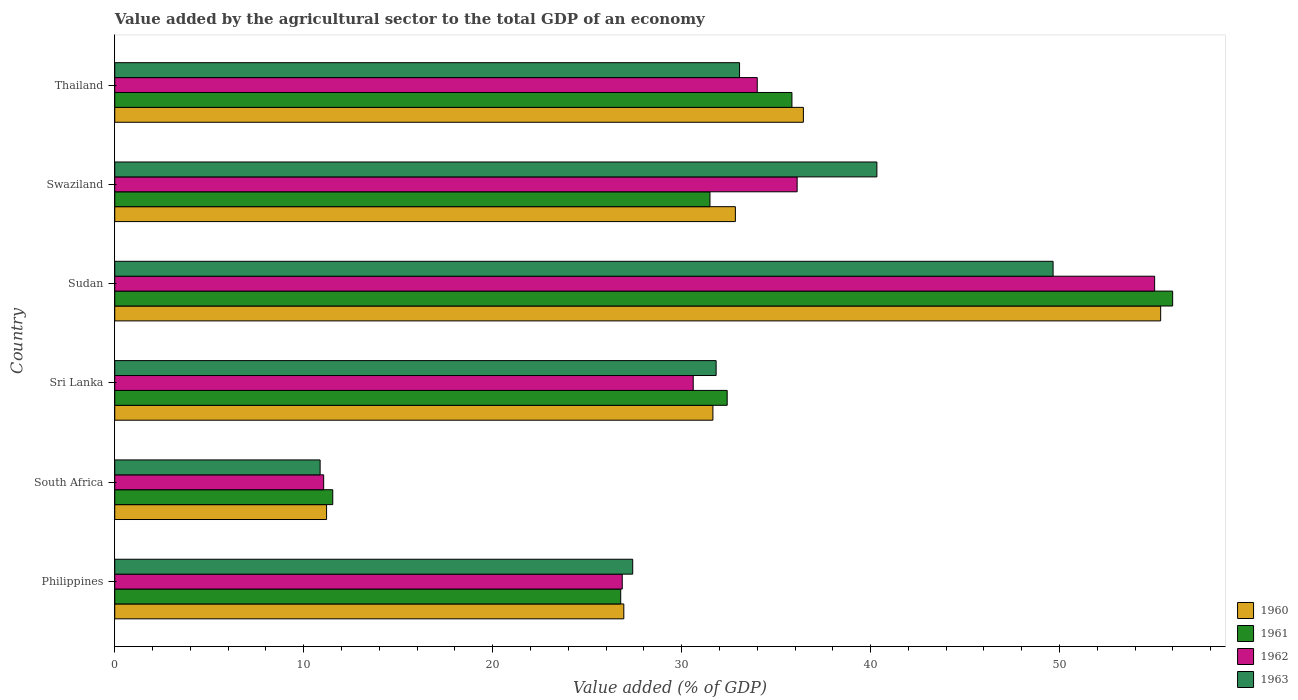How many different coloured bars are there?
Provide a short and direct response. 4. How many groups of bars are there?
Offer a very short reply. 6. Are the number of bars on each tick of the Y-axis equal?
Offer a terse response. Yes. How many bars are there on the 4th tick from the bottom?
Offer a very short reply. 4. What is the value added by the agricultural sector to the total GDP in 1962 in Thailand?
Your answer should be very brief. 34. Across all countries, what is the maximum value added by the agricultural sector to the total GDP in 1960?
Provide a short and direct response. 55.35. Across all countries, what is the minimum value added by the agricultural sector to the total GDP in 1960?
Ensure brevity in your answer.  11.21. In which country was the value added by the agricultural sector to the total GDP in 1963 maximum?
Make the answer very short. Sudan. In which country was the value added by the agricultural sector to the total GDP in 1963 minimum?
Your answer should be very brief. South Africa. What is the total value added by the agricultural sector to the total GDP in 1963 in the graph?
Give a very brief answer. 193.16. What is the difference between the value added by the agricultural sector to the total GDP in 1960 in Philippines and that in Sudan?
Ensure brevity in your answer.  -28.41. What is the difference between the value added by the agricultural sector to the total GDP in 1961 in Sudan and the value added by the agricultural sector to the total GDP in 1962 in Thailand?
Provide a short and direct response. 21.98. What is the average value added by the agricultural sector to the total GDP in 1960 per country?
Offer a very short reply. 32.41. What is the difference between the value added by the agricultural sector to the total GDP in 1963 and value added by the agricultural sector to the total GDP in 1962 in Sudan?
Give a very brief answer. -5.37. What is the ratio of the value added by the agricultural sector to the total GDP in 1963 in South Africa to that in Swaziland?
Keep it short and to the point. 0.27. What is the difference between the highest and the second highest value added by the agricultural sector to the total GDP in 1961?
Your answer should be compact. 20.15. What is the difference between the highest and the lowest value added by the agricultural sector to the total GDP in 1961?
Your answer should be very brief. 44.45. In how many countries, is the value added by the agricultural sector to the total GDP in 1962 greater than the average value added by the agricultural sector to the total GDP in 1962 taken over all countries?
Offer a very short reply. 3. Is it the case that in every country, the sum of the value added by the agricultural sector to the total GDP in 1961 and value added by the agricultural sector to the total GDP in 1963 is greater than the sum of value added by the agricultural sector to the total GDP in 1960 and value added by the agricultural sector to the total GDP in 1962?
Keep it short and to the point. No. What does the 2nd bar from the top in Swaziland represents?
Your answer should be very brief. 1962. What does the 3rd bar from the bottom in Swaziland represents?
Provide a succinct answer. 1962. Is it the case that in every country, the sum of the value added by the agricultural sector to the total GDP in 1963 and value added by the agricultural sector to the total GDP in 1962 is greater than the value added by the agricultural sector to the total GDP in 1961?
Give a very brief answer. Yes. Are all the bars in the graph horizontal?
Provide a short and direct response. Yes. How many countries are there in the graph?
Offer a terse response. 6. What is the difference between two consecutive major ticks on the X-axis?
Ensure brevity in your answer.  10. Does the graph contain any zero values?
Offer a very short reply. No. Where does the legend appear in the graph?
Give a very brief answer. Bottom right. How many legend labels are there?
Your response must be concise. 4. What is the title of the graph?
Make the answer very short. Value added by the agricultural sector to the total GDP of an economy. What is the label or title of the X-axis?
Your response must be concise. Value added (% of GDP). What is the label or title of the Y-axis?
Ensure brevity in your answer.  Country. What is the Value added (% of GDP) of 1960 in Philippines?
Your response must be concise. 26.94. What is the Value added (% of GDP) in 1961 in Philippines?
Your answer should be very brief. 26.78. What is the Value added (% of GDP) in 1962 in Philippines?
Keep it short and to the point. 26.86. What is the Value added (% of GDP) of 1963 in Philippines?
Make the answer very short. 27.41. What is the Value added (% of GDP) of 1960 in South Africa?
Keep it short and to the point. 11.21. What is the Value added (% of GDP) of 1961 in South Africa?
Your response must be concise. 11.54. What is the Value added (% of GDP) in 1962 in South Africa?
Ensure brevity in your answer.  11.06. What is the Value added (% of GDP) in 1963 in South Africa?
Your answer should be very brief. 10.87. What is the Value added (% of GDP) of 1960 in Sri Lanka?
Offer a terse response. 31.66. What is the Value added (% of GDP) in 1961 in Sri Lanka?
Make the answer very short. 32.41. What is the Value added (% of GDP) of 1962 in Sri Lanka?
Provide a succinct answer. 30.61. What is the Value added (% of GDP) of 1963 in Sri Lanka?
Your answer should be very brief. 31.83. What is the Value added (% of GDP) in 1960 in Sudan?
Provide a succinct answer. 55.35. What is the Value added (% of GDP) of 1961 in Sudan?
Offer a very short reply. 55.99. What is the Value added (% of GDP) in 1962 in Sudan?
Give a very brief answer. 55.03. What is the Value added (% of GDP) of 1963 in Sudan?
Make the answer very short. 49.66. What is the Value added (% of GDP) of 1960 in Swaziland?
Make the answer very short. 32.84. What is the Value added (% of GDP) in 1961 in Swaziland?
Offer a terse response. 31.5. What is the Value added (% of GDP) of 1962 in Swaziland?
Offer a very short reply. 36.11. What is the Value added (% of GDP) in 1963 in Swaziland?
Your answer should be very brief. 40.33. What is the Value added (% of GDP) in 1960 in Thailand?
Offer a terse response. 36.44. What is the Value added (% of GDP) in 1961 in Thailand?
Ensure brevity in your answer.  35.84. What is the Value added (% of GDP) of 1962 in Thailand?
Offer a very short reply. 34. What is the Value added (% of GDP) in 1963 in Thailand?
Provide a short and direct response. 33.07. Across all countries, what is the maximum Value added (% of GDP) of 1960?
Provide a succinct answer. 55.35. Across all countries, what is the maximum Value added (% of GDP) in 1961?
Your answer should be very brief. 55.99. Across all countries, what is the maximum Value added (% of GDP) of 1962?
Provide a succinct answer. 55.03. Across all countries, what is the maximum Value added (% of GDP) of 1963?
Give a very brief answer. 49.66. Across all countries, what is the minimum Value added (% of GDP) of 1960?
Your answer should be very brief. 11.21. Across all countries, what is the minimum Value added (% of GDP) in 1961?
Give a very brief answer. 11.54. Across all countries, what is the minimum Value added (% of GDP) in 1962?
Your answer should be very brief. 11.06. Across all countries, what is the minimum Value added (% of GDP) of 1963?
Ensure brevity in your answer.  10.87. What is the total Value added (% of GDP) in 1960 in the graph?
Make the answer very short. 194.45. What is the total Value added (% of GDP) of 1961 in the graph?
Offer a very short reply. 194.05. What is the total Value added (% of GDP) in 1962 in the graph?
Offer a very short reply. 193.68. What is the total Value added (% of GDP) of 1963 in the graph?
Ensure brevity in your answer.  193.16. What is the difference between the Value added (% of GDP) in 1960 in Philippines and that in South Africa?
Ensure brevity in your answer.  15.73. What is the difference between the Value added (% of GDP) of 1961 in Philippines and that in South Africa?
Offer a very short reply. 15.24. What is the difference between the Value added (% of GDP) of 1962 in Philippines and that in South Africa?
Give a very brief answer. 15.8. What is the difference between the Value added (% of GDP) in 1963 in Philippines and that in South Africa?
Offer a terse response. 16.54. What is the difference between the Value added (% of GDP) in 1960 in Philippines and that in Sri Lanka?
Your response must be concise. -4.72. What is the difference between the Value added (% of GDP) in 1961 in Philippines and that in Sri Lanka?
Your answer should be compact. -5.63. What is the difference between the Value added (% of GDP) in 1962 in Philippines and that in Sri Lanka?
Offer a terse response. -3.76. What is the difference between the Value added (% of GDP) in 1963 in Philippines and that in Sri Lanka?
Ensure brevity in your answer.  -4.41. What is the difference between the Value added (% of GDP) of 1960 in Philippines and that in Sudan?
Ensure brevity in your answer.  -28.41. What is the difference between the Value added (% of GDP) in 1961 in Philippines and that in Sudan?
Give a very brief answer. -29.21. What is the difference between the Value added (% of GDP) of 1962 in Philippines and that in Sudan?
Make the answer very short. -28.18. What is the difference between the Value added (% of GDP) in 1963 in Philippines and that in Sudan?
Offer a terse response. -22.25. What is the difference between the Value added (% of GDP) of 1960 in Philippines and that in Swaziland?
Give a very brief answer. -5.9. What is the difference between the Value added (% of GDP) in 1961 in Philippines and that in Swaziland?
Provide a succinct answer. -4.72. What is the difference between the Value added (% of GDP) of 1962 in Philippines and that in Swaziland?
Give a very brief answer. -9.26. What is the difference between the Value added (% of GDP) of 1963 in Philippines and that in Swaziland?
Your response must be concise. -12.92. What is the difference between the Value added (% of GDP) of 1960 in Philippines and that in Thailand?
Offer a terse response. -9.5. What is the difference between the Value added (% of GDP) in 1961 in Philippines and that in Thailand?
Keep it short and to the point. -9.06. What is the difference between the Value added (% of GDP) of 1962 in Philippines and that in Thailand?
Your response must be concise. -7.14. What is the difference between the Value added (% of GDP) in 1963 in Philippines and that in Thailand?
Provide a short and direct response. -5.65. What is the difference between the Value added (% of GDP) in 1960 in South Africa and that in Sri Lanka?
Provide a short and direct response. -20.45. What is the difference between the Value added (% of GDP) of 1961 in South Africa and that in Sri Lanka?
Give a very brief answer. -20.87. What is the difference between the Value added (% of GDP) of 1962 in South Africa and that in Sri Lanka?
Your response must be concise. -19.56. What is the difference between the Value added (% of GDP) in 1963 in South Africa and that in Sri Lanka?
Provide a short and direct response. -20.96. What is the difference between the Value added (% of GDP) in 1960 in South Africa and that in Sudan?
Offer a very short reply. -44.14. What is the difference between the Value added (% of GDP) of 1961 in South Africa and that in Sudan?
Ensure brevity in your answer.  -44.45. What is the difference between the Value added (% of GDP) of 1962 in South Africa and that in Sudan?
Give a very brief answer. -43.98. What is the difference between the Value added (% of GDP) of 1963 in South Africa and that in Sudan?
Make the answer very short. -38.79. What is the difference between the Value added (% of GDP) in 1960 in South Africa and that in Swaziland?
Your response must be concise. -21.63. What is the difference between the Value added (% of GDP) of 1961 in South Africa and that in Swaziland?
Ensure brevity in your answer.  -19.96. What is the difference between the Value added (% of GDP) in 1962 in South Africa and that in Swaziland?
Your answer should be very brief. -25.06. What is the difference between the Value added (% of GDP) in 1963 in South Africa and that in Swaziland?
Provide a short and direct response. -29.46. What is the difference between the Value added (% of GDP) in 1960 in South Africa and that in Thailand?
Your response must be concise. -25.23. What is the difference between the Value added (% of GDP) of 1961 in South Africa and that in Thailand?
Offer a very short reply. -24.3. What is the difference between the Value added (% of GDP) of 1962 in South Africa and that in Thailand?
Your answer should be very brief. -22.95. What is the difference between the Value added (% of GDP) of 1963 in South Africa and that in Thailand?
Keep it short and to the point. -22.2. What is the difference between the Value added (% of GDP) in 1960 in Sri Lanka and that in Sudan?
Your answer should be very brief. -23.7. What is the difference between the Value added (% of GDP) of 1961 in Sri Lanka and that in Sudan?
Provide a succinct answer. -23.58. What is the difference between the Value added (% of GDP) of 1962 in Sri Lanka and that in Sudan?
Your response must be concise. -24.42. What is the difference between the Value added (% of GDP) of 1963 in Sri Lanka and that in Sudan?
Ensure brevity in your answer.  -17.83. What is the difference between the Value added (% of GDP) of 1960 in Sri Lanka and that in Swaziland?
Keep it short and to the point. -1.19. What is the difference between the Value added (% of GDP) of 1961 in Sri Lanka and that in Swaziland?
Provide a short and direct response. 0.91. What is the difference between the Value added (% of GDP) in 1962 in Sri Lanka and that in Swaziland?
Make the answer very short. -5.5. What is the difference between the Value added (% of GDP) in 1963 in Sri Lanka and that in Swaziland?
Your answer should be compact. -8.51. What is the difference between the Value added (% of GDP) of 1960 in Sri Lanka and that in Thailand?
Keep it short and to the point. -4.79. What is the difference between the Value added (% of GDP) in 1961 in Sri Lanka and that in Thailand?
Provide a short and direct response. -3.43. What is the difference between the Value added (% of GDP) of 1962 in Sri Lanka and that in Thailand?
Offer a terse response. -3.39. What is the difference between the Value added (% of GDP) in 1963 in Sri Lanka and that in Thailand?
Provide a short and direct response. -1.24. What is the difference between the Value added (% of GDP) of 1960 in Sudan and that in Swaziland?
Offer a terse response. 22.51. What is the difference between the Value added (% of GDP) in 1961 in Sudan and that in Swaziland?
Give a very brief answer. 24.49. What is the difference between the Value added (% of GDP) in 1962 in Sudan and that in Swaziland?
Keep it short and to the point. 18.92. What is the difference between the Value added (% of GDP) in 1963 in Sudan and that in Swaziland?
Ensure brevity in your answer.  9.32. What is the difference between the Value added (% of GDP) in 1960 in Sudan and that in Thailand?
Your response must be concise. 18.91. What is the difference between the Value added (% of GDP) of 1961 in Sudan and that in Thailand?
Provide a short and direct response. 20.15. What is the difference between the Value added (% of GDP) of 1962 in Sudan and that in Thailand?
Give a very brief answer. 21.03. What is the difference between the Value added (% of GDP) in 1963 in Sudan and that in Thailand?
Make the answer very short. 16.59. What is the difference between the Value added (% of GDP) of 1960 in Swaziland and that in Thailand?
Keep it short and to the point. -3.6. What is the difference between the Value added (% of GDP) in 1961 in Swaziland and that in Thailand?
Offer a very short reply. -4.34. What is the difference between the Value added (% of GDP) in 1962 in Swaziland and that in Thailand?
Keep it short and to the point. 2.11. What is the difference between the Value added (% of GDP) of 1963 in Swaziland and that in Thailand?
Offer a terse response. 7.27. What is the difference between the Value added (% of GDP) of 1960 in Philippines and the Value added (% of GDP) of 1961 in South Africa?
Offer a terse response. 15.4. What is the difference between the Value added (% of GDP) of 1960 in Philippines and the Value added (% of GDP) of 1962 in South Africa?
Provide a short and direct response. 15.88. What is the difference between the Value added (% of GDP) in 1960 in Philippines and the Value added (% of GDP) in 1963 in South Africa?
Keep it short and to the point. 16.07. What is the difference between the Value added (% of GDP) of 1961 in Philippines and the Value added (% of GDP) of 1962 in South Africa?
Provide a succinct answer. 15.72. What is the difference between the Value added (% of GDP) of 1961 in Philippines and the Value added (% of GDP) of 1963 in South Africa?
Offer a very short reply. 15.91. What is the difference between the Value added (% of GDP) of 1962 in Philippines and the Value added (% of GDP) of 1963 in South Africa?
Make the answer very short. 15.99. What is the difference between the Value added (% of GDP) of 1960 in Philippines and the Value added (% of GDP) of 1961 in Sri Lanka?
Ensure brevity in your answer.  -5.47. What is the difference between the Value added (% of GDP) in 1960 in Philippines and the Value added (% of GDP) in 1962 in Sri Lanka?
Your answer should be compact. -3.67. What is the difference between the Value added (% of GDP) in 1960 in Philippines and the Value added (% of GDP) in 1963 in Sri Lanka?
Keep it short and to the point. -4.89. What is the difference between the Value added (% of GDP) in 1961 in Philippines and the Value added (% of GDP) in 1962 in Sri Lanka?
Ensure brevity in your answer.  -3.84. What is the difference between the Value added (% of GDP) in 1961 in Philippines and the Value added (% of GDP) in 1963 in Sri Lanka?
Offer a terse response. -5.05. What is the difference between the Value added (% of GDP) of 1962 in Philippines and the Value added (% of GDP) of 1963 in Sri Lanka?
Give a very brief answer. -4.97. What is the difference between the Value added (% of GDP) of 1960 in Philippines and the Value added (% of GDP) of 1961 in Sudan?
Your response must be concise. -29.05. What is the difference between the Value added (% of GDP) in 1960 in Philippines and the Value added (% of GDP) in 1962 in Sudan?
Your answer should be compact. -28.09. What is the difference between the Value added (% of GDP) of 1960 in Philippines and the Value added (% of GDP) of 1963 in Sudan?
Offer a very short reply. -22.72. What is the difference between the Value added (% of GDP) of 1961 in Philippines and the Value added (% of GDP) of 1962 in Sudan?
Offer a very short reply. -28.26. What is the difference between the Value added (% of GDP) in 1961 in Philippines and the Value added (% of GDP) in 1963 in Sudan?
Your answer should be very brief. -22.88. What is the difference between the Value added (% of GDP) of 1962 in Philippines and the Value added (% of GDP) of 1963 in Sudan?
Your answer should be very brief. -22.8. What is the difference between the Value added (% of GDP) in 1960 in Philippines and the Value added (% of GDP) in 1961 in Swaziland?
Keep it short and to the point. -4.56. What is the difference between the Value added (% of GDP) in 1960 in Philippines and the Value added (% of GDP) in 1962 in Swaziland?
Keep it short and to the point. -9.17. What is the difference between the Value added (% of GDP) in 1960 in Philippines and the Value added (% of GDP) in 1963 in Swaziland?
Provide a short and direct response. -13.39. What is the difference between the Value added (% of GDP) of 1961 in Philippines and the Value added (% of GDP) of 1962 in Swaziland?
Offer a very short reply. -9.34. What is the difference between the Value added (% of GDP) of 1961 in Philippines and the Value added (% of GDP) of 1963 in Swaziland?
Give a very brief answer. -13.56. What is the difference between the Value added (% of GDP) in 1962 in Philippines and the Value added (% of GDP) in 1963 in Swaziland?
Your response must be concise. -13.48. What is the difference between the Value added (% of GDP) in 1960 in Philippines and the Value added (% of GDP) in 1961 in Thailand?
Make the answer very short. -8.9. What is the difference between the Value added (% of GDP) in 1960 in Philippines and the Value added (% of GDP) in 1962 in Thailand?
Your answer should be compact. -7.06. What is the difference between the Value added (% of GDP) in 1960 in Philippines and the Value added (% of GDP) in 1963 in Thailand?
Your answer should be compact. -6.12. What is the difference between the Value added (% of GDP) in 1961 in Philippines and the Value added (% of GDP) in 1962 in Thailand?
Offer a terse response. -7.23. What is the difference between the Value added (% of GDP) in 1961 in Philippines and the Value added (% of GDP) in 1963 in Thailand?
Your answer should be very brief. -6.29. What is the difference between the Value added (% of GDP) in 1962 in Philippines and the Value added (% of GDP) in 1963 in Thailand?
Provide a succinct answer. -6.21. What is the difference between the Value added (% of GDP) in 1960 in South Africa and the Value added (% of GDP) in 1961 in Sri Lanka?
Your answer should be compact. -21.2. What is the difference between the Value added (% of GDP) in 1960 in South Africa and the Value added (% of GDP) in 1962 in Sri Lanka?
Your response must be concise. -19.4. What is the difference between the Value added (% of GDP) in 1960 in South Africa and the Value added (% of GDP) in 1963 in Sri Lanka?
Provide a short and direct response. -20.62. What is the difference between the Value added (% of GDP) in 1961 in South Africa and the Value added (% of GDP) in 1962 in Sri Lanka?
Your answer should be very brief. -19.08. What is the difference between the Value added (% of GDP) in 1961 in South Africa and the Value added (% of GDP) in 1963 in Sri Lanka?
Your response must be concise. -20.29. What is the difference between the Value added (% of GDP) of 1962 in South Africa and the Value added (% of GDP) of 1963 in Sri Lanka?
Keep it short and to the point. -20.77. What is the difference between the Value added (% of GDP) in 1960 in South Africa and the Value added (% of GDP) in 1961 in Sudan?
Give a very brief answer. -44.78. What is the difference between the Value added (% of GDP) in 1960 in South Africa and the Value added (% of GDP) in 1962 in Sudan?
Provide a succinct answer. -43.82. What is the difference between the Value added (% of GDP) in 1960 in South Africa and the Value added (% of GDP) in 1963 in Sudan?
Make the answer very short. -38.45. What is the difference between the Value added (% of GDP) of 1961 in South Africa and the Value added (% of GDP) of 1962 in Sudan?
Your response must be concise. -43.5. What is the difference between the Value added (% of GDP) of 1961 in South Africa and the Value added (% of GDP) of 1963 in Sudan?
Ensure brevity in your answer.  -38.12. What is the difference between the Value added (% of GDP) of 1962 in South Africa and the Value added (% of GDP) of 1963 in Sudan?
Your response must be concise. -38.6. What is the difference between the Value added (% of GDP) of 1960 in South Africa and the Value added (% of GDP) of 1961 in Swaziland?
Your response must be concise. -20.29. What is the difference between the Value added (% of GDP) in 1960 in South Africa and the Value added (% of GDP) in 1962 in Swaziland?
Provide a short and direct response. -24.9. What is the difference between the Value added (% of GDP) of 1960 in South Africa and the Value added (% of GDP) of 1963 in Swaziland?
Give a very brief answer. -29.12. What is the difference between the Value added (% of GDP) of 1961 in South Africa and the Value added (% of GDP) of 1962 in Swaziland?
Your response must be concise. -24.58. What is the difference between the Value added (% of GDP) in 1961 in South Africa and the Value added (% of GDP) in 1963 in Swaziland?
Your answer should be very brief. -28.8. What is the difference between the Value added (% of GDP) of 1962 in South Africa and the Value added (% of GDP) of 1963 in Swaziland?
Ensure brevity in your answer.  -29.28. What is the difference between the Value added (% of GDP) in 1960 in South Africa and the Value added (% of GDP) in 1961 in Thailand?
Offer a very short reply. -24.63. What is the difference between the Value added (% of GDP) of 1960 in South Africa and the Value added (% of GDP) of 1962 in Thailand?
Make the answer very short. -22.79. What is the difference between the Value added (% of GDP) of 1960 in South Africa and the Value added (% of GDP) of 1963 in Thailand?
Offer a very short reply. -21.86. What is the difference between the Value added (% of GDP) in 1961 in South Africa and the Value added (% of GDP) in 1962 in Thailand?
Provide a succinct answer. -22.47. What is the difference between the Value added (% of GDP) in 1961 in South Africa and the Value added (% of GDP) in 1963 in Thailand?
Make the answer very short. -21.53. What is the difference between the Value added (% of GDP) of 1962 in South Africa and the Value added (% of GDP) of 1963 in Thailand?
Provide a short and direct response. -22.01. What is the difference between the Value added (% of GDP) of 1960 in Sri Lanka and the Value added (% of GDP) of 1961 in Sudan?
Provide a succinct answer. -24.33. What is the difference between the Value added (% of GDP) in 1960 in Sri Lanka and the Value added (% of GDP) in 1962 in Sudan?
Your answer should be very brief. -23.38. What is the difference between the Value added (% of GDP) of 1960 in Sri Lanka and the Value added (% of GDP) of 1963 in Sudan?
Your response must be concise. -18. What is the difference between the Value added (% of GDP) of 1961 in Sri Lanka and the Value added (% of GDP) of 1962 in Sudan?
Give a very brief answer. -22.62. What is the difference between the Value added (% of GDP) of 1961 in Sri Lanka and the Value added (% of GDP) of 1963 in Sudan?
Make the answer very short. -17.25. What is the difference between the Value added (% of GDP) in 1962 in Sri Lanka and the Value added (% of GDP) in 1963 in Sudan?
Provide a succinct answer. -19.04. What is the difference between the Value added (% of GDP) of 1960 in Sri Lanka and the Value added (% of GDP) of 1961 in Swaziland?
Provide a short and direct response. 0.16. What is the difference between the Value added (% of GDP) of 1960 in Sri Lanka and the Value added (% of GDP) of 1962 in Swaziland?
Give a very brief answer. -4.46. What is the difference between the Value added (% of GDP) of 1960 in Sri Lanka and the Value added (% of GDP) of 1963 in Swaziland?
Your response must be concise. -8.68. What is the difference between the Value added (% of GDP) of 1961 in Sri Lanka and the Value added (% of GDP) of 1962 in Swaziland?
Provide a succinct answer. -3.7. What is the difference between the Value added (% of GDP) of 1961 in Sri Lanka and the Value added (% of GDP) of 1963 in Swaziland?
Your answer should be compact. -7.92. What is the difference between the Value added (% of GDP) of 1962 in Sri Lanka and the Value added (% of GDP) of 1963 in Swaziland?
Give a very brief answer. -9.72. What is the difference between the Value added (% of GDP) of 1960 in Sri Lanka and the Value added (% of GDP) of 1961 in Thailand?
Provide a short and direct response. -4.18. What is the difference between the Value added (% of GDP) of 1960 in Sri Lanka and the Value added (% of GDP) of 1962 in Thailand?
Keep it short and to the point. -2.35. What is the difference between the Value added (% of GDP) of 1960 in Sri Lanka and the Value added (% of GDP) of 1963 in Thailand?
Ensure brevity in your answer.  -1.41. What is the difference between the Value added (% of GDP) of 1961 in Sri Lanka and the Value added (% of GDP) of 1962 in Thailand?
Your response must be concise. -1.59. What is the difference between the Value added (% of GDP) in 1961 in Sri Lanka and the Value added (% of GDP) in 1963 in Thailand?
Give a very brief answer. -0.65. What is the difference between the Value added (% of GDP) in 1962 in Sri Lanka and the Value added (% of GDP) in 1963 in Thailand?
Your answer should be very brief. -2.45. What is the difference between the Value added (% of GDP) of 1960 in Sudan and the Value added (% of GDP) of 1961 in Swaziland?
Your response must be concise. 23.85. What is the difference between the Value added (% of GDP) in 1960 in Sudan and the Value added (% of GDP) in 1962 in Swaziland?
Offer a terse response. 19.24. What is the difference between the Value added (% of GDP) in 1960 in Sudan and the Value added (% of GDP) in 1963 in Swaziland?
Provide a short and direct response. 15.02. What is the difference between the Value added (% of GDP) in 1961 in Sudan and the Value added (% of GDP) in 1962 in Swaziland?
Keep it short and to the point. 19.87. What is the difference between the Value added (% of GDP) in 1961 in Sudan and the Value added (% of GDP) in 1963 in Swaziland?
Offer a very short reply. 15.65. What is the difference between the Value added (% of GDP) of 1962 in Sudan and the Value added (% of GDP) of 1963 in Swaziland?
Give a very brief answer. 14.7. What is the difference between the Value added (% of GDP) of 1960 in Sudan and the Value added (% of GDP) of 1961 in Thailand?
Ensure brevity in your answer.  19.51. What is the difference between the Value added (% of GDP) of 1960 in Sudan and the Value added (% of GDP) of 1962 in Thailand?
Make the answer very short. 21.35. What is the difference between the Value added (% of GDP) in 1960 in Sudan and the Value added (% of GDP) in 1963 in Thailand?
Offer a very short reply. 22.29. What is the difference between the Value added (% of GDP) of 1961 in Sudan and the Value added (% of GDP) of 1962 in Thailand?
Your answer should be very brief. 21.98. What is the difference between the Value added (% of GDP) in 1961 in Sudan and the Value added (% of GDP) in 1963 in Thailand?
Provide a succinct answer. 22.92. What is the difference between the Value added (% of GDP) of 1962 in Sudan and the Value added (% of GDP) of 1963 in Thailand?
Ensure brevity in your answer.  21.97. What is the difference between the Value added (% of GDP) in 1960 in Swaziland and the Value added (% of GDP) in 1961 in Thailand?
Provide a short and direct response. -2.99. What is the difference between the Value added (% of GDP) of 1960 in Swaziland and the Value added (% of GDP) of 1962 in Thailand?
Offer a very short reply. -1.16. What is the difference between the Value added (% of GDP) in 1960 in Swaziland and the Value added (% of GDP) in 1963 in Thailand?
Ensure brevity in your answer.  -0.22. What is the difference between the Value added (% of GDP) in 1961 in Swaziland and the Value added (% of GDP) in 1962 in Thailand?
Offer a terse response. -2.5. What is the difference between the Value added (% of GDP) in 1961 in Swaziland and the Value added (% of GDP) in 1963 in Thailand?
Offer a terse response. -1.57. What is the difference between the Value added (% of GDP) in 1962 in Swaziland and the Value added (% of GDP) in 1963 in Thailand?
Give a very brief answer. 3.05. What is the average Value added (% of GDP) in 1960 per country?
Your response must be concise. 32.41. What is the average Value added (% of GDP) of 1961 per country?
Your response must be concise. 32.34. What is the average Value added (% of GDP) in 1962 per country?
Provide a succinct answer. 32.28. What is the average Value added (% of GDP) in 1963 per country?
Your answer should be very brief. 32.19. What is the difference between the Value added (% of GDP) in 1960 and Value added (% of GDP) in 1961 in Philippines?
Give a very brief answer. 0.16. What is the difference between the Value added (% of GDP) in 1960 and Value added (% of GDP) in 1962 in Philippines?
Provide a short and direct response. 0.08. What is the difference between the Value added (% of GDP) in 1960 and Value added (% of GDP) in 1963 in Philippines?
Give a very brief answer. -0.47. What is the difference between the Value added (% of GDP) in 1961 and Value added (% of GDP) in 1962 in Philippines?
Keep it short and to the point. -0.08. What is the difference between the Value added (% of GDP) in 1961 and Value added (% of GDP) in 1963 in Philippines?
Give a very brief answer. -0.64. What is the difference between the Value added (% of GDP) in 1962 and Value added (% of GDP) in 1963 in Philippines?
Provide a short and direct response. -0.55. What is the difference between the Value added (% of GDP) in 1960 and Value added (% of GDP) in 1961 in South Africa?
Your response must be concise. -0.33. What is the difference between the Value added (% of GDP) of 1960 and Value added (% of GDP) of 1962 in South Africa?
Provide a succinct answer. 0.15. What is the difference between the Value added (% of GDP) in 1960 and Value added (% of GDP) in 1963 in South Africa?
Provide a succinct answer. 0.34. What is the difference between the Value added (% of GDP) in 1961 and Value added (% of GDP) in 1962 in South Africa?
Provide a short and direct response. 0.48. What is the difference between the Value added (% of GDP) of 1961 and Value added (% of GDP) of 1963 in South Africa?
Your response must be concise. 0.67. What is the difference between the Value added (% of GDP) of 1962 and Value added (% of GDP) of 1963 in South Africa?
Your answer should be very brief. 0.19. What is the difference between the Value added (% of GDP) of 1960 and Value added (% of GDP) of 1961 in Sri Lanka?
Offer a very short reply. -0.76. What is the difference between the Value added (% of GDP) of 1960 and Value added (% of GDP) of 1962 in Sri Lanka?
Offer a very short reply. 1.04. What is the difference between the Value added (% of GDP) of 1960 and Value added (% of GDP) of 1963 in Sri Lanka?
Your answer should be compact. -0.17. What is the difference between the Value added (% of GDP) of 1961 and Value added (% of GDP) of 1962 in Sri Lanka?
Provide a succinct answer. 1.8. What is the difference between the Value added (% of GDP) in 1961 and Value added (% of GDP) in 1963 in Sri Lanka?
Offer a terse response. 0.59. What is the difference between the Value added (% of GDP) in 1962 and Value added (% of GDP) in 1963 in Sri Lanka?
Your answer should be compact. -1.21. What is the difference between the Value added (% of GDP) in 1960 and Value added (% of GDP) in 1961 in Sudan?
Ensure brevity in your answer.  -0.64. What is the difference between the Value added (% of GDP) in 1960 and Value added (% of GDP) in 1962 in Sudan?
Your response must be concise. 0.32. What is the difference between the Value added (% of GDP) of 1960 and Value added (% of GDP) of 1963 in Sudan?
Keep it short and to the point. 5.69. What is the difference between the Value added (% of GDP) in 1961 and Value added (% of GDP) in 1962 in Sudan?
Your answer should be very brief. 0.95. What is the difference between the Value added (% of GDP) of 1961 and Value added (% of GDP) of 1963 in Sudan?
Your answer should be very brief. 6.33. What is the difference between the Value added (% of GDP) in 1962 and Value added (% of GDP) in 1963 in Sudan?
Your response must be concise. 5.37. What is the difference between the Value added (% of GDP) in 1960 and Value added (% of GDP) in 1961 in Swaziland?
Offer a very short reply. 1.35. What is the difference between the Value added (% of GDP) in 1960 and Value added (% of GDP) in 1962 in Swaziland?
Provide a succinct answer. -3.27. What is the difference between the Value added (% of GDP) in 1960 and Value added (% of GDP) in 1963 in Swaziland?
Your answer should be compact. -7.49. What is the difference between the Value added (% of GDP) in 1961 and Value added (% of GDP) in 1962 in Swaziland?
Your response must be concise. -4.61. What is the difference between the Value added (% of GDP) in 1961 and Value added (% of GDP) in 1963 in Swaziland?
Your answer should be very brief. -8.83. What is the difference between the Value added (% of GDP) in 1962 and Value added (% of GDP) in 1963 in Swaziland?
Keep it short and to the point. -4.22. What is the difference between the Value added (% of GDP) in 1960 and Value added (% of GDP) in 1961 in Thailand?
Your answer should be very brief. 0.61. What is the difference between the Value added (% of GDP) in 1960 and Value added (% of GDP) in 1962 in Thailand?
Your answer should be compact. 2.44. What is the difference between the Value added (% of GDP) of 1960 and Value added (% of GDP) of 1963 in Thailand?
Your response must be concise. 3.38. What is the difference between the Value added (% of GDP) of 1961 and Value added (% of GDP) of 1962 in Thailand?
Give a very brief answer. 1.84. What is the difference between the Value added (% of GDP) of 1961 and Value added (% of GDP) of 1963 in Thailand?
Offer a very short reply. 2.77. What is the difference between the Value added (% of GDP) of 1962 and Value added (% of GDP) of 1963 in Thailand?
Your answer should be compact. 0.94. What is the ratio of the Value added (% of GDP) of 1960 in Philippines to that in South Africa?
Offer a very short reply. 2.4. What is the ratio of the Value added (% of GDP) of 1961 in Philippines to that in South Africa?
Offer a terse response. 2.32. What is the ratio of the Value added (% of GDP) of 1962 in Philippines to that in South Africa?
Offer a terse response. 2.43. What is the ratio of the Value added (% of GDP) of 1963 in Philippines to that in South Africa?
Your answer should be very brief. 2.52. What is the ratio of the Value added (% of GDP) in 1960 in Philippines to that in Sri Lanka?
Provide a succinct answer. 0.85. What is the ratio of the Value added (% of GDP) of 1961 in Philippines to that in Sri Lanka?
Keep it short and to the point. 0.83. What is the ratio of the Value added (% of GDP) in 1962 in Philippines to that in Sri Lanka?
Your answer should be very brief. 0.88. What is the ratio of the Value added (% of GDP) of 1963 in Philippines to that in Sri Lanka?
Offer a very short reply. 0.86. What is the ratio of the Value added (% of GDP) of 1960 in Philippines to that in Sudan?
Make the answer very short. 0.49. What is the ratio of the Value added (% of GDP) of 1961 in Philippines to that in Sudan?
Your response must be concise. 0.48. What is the ratio of the Value added (% of GDP) of 1962 in Philippines to that in Sudan?
Your response must be concise. 0.49. What is the ratio of the Value added (% of GDP) of 1963 in Philippines to that in Sudan?
Provide a short and direct response. 0.55. What is the ratio of the Value added (% of GDP) in 1960 in Philippines to that in Swaziland?
Give a very brief answer. 0.82. What is the ratio of the Value added (% of GDP) in 1961 in Philippines to that in Swaziland?
Your response must be concise. 0.85. What is the ratio of the Value added (% of GDP) in 1962 in Philippines to that in Swaziland?
Your response must be concise. 0.74. What is the ratio of the Value added (% of GDP) of 1963 in Philippines to that in Swaziland?
Keep it short and to the point. 0.68. What is the ratio of the Value added (% of GDP) in 1960 in Philippines to that in Thailand?
Offer a very short reply. 0.74. What is the ratio of the Value added (% of GDP) in 1961 in Philippines to that in Thailand?
Keep it short and to the point. 0.75. What is the ratio of the Value added (% of GDP) in 1962 in Philippines to that in Thailand?
Provide a short and direct response. 0.79. What is the ratio of the Value added (% of GDP) in 1963 in Philippines to that in Thailand?
Provide a short and direct response. 0.83. What is the ratio of the Value added (% of GDP) of 1960 in South Africa to that in Sri Lanka?
Keep it short and to the point. 0.35. What is the ratio of the Value added (% of GDP) in 1961 in South Africa to that in Sri Lanka?
Your answer should be very brief. 0.36. What is the ratio of the Value added (% of GDP) of 1962 in South Africa to that in Sri Lanka?
Your response must be concise. 0.36. What is the ratio of the Value added (% of GDP) of 1963 in South Africa to that in Sri Lanka?
Keep it short and to the point. 0.34. What is the ratio of the Value added (% of GDP) of 1960 in South Africa to that in Sudan?
Offer a terse response. 0.2. What is the ratio of the Value added (% of GDP) in 1961 in South Africa to that in Sudan?
Provide a succinct answer. 0.21. What is the ratio of the Value added (% of GDP) in 1962 in South Africa to that in Sudan?
Your response must be concise. 0.2. What is the ratio of the Value added (% of GDP) in 1963 in South Africa to that in Sudan?
Give a very brief answer. 0.22. What is the ratio of the Value added (% of GDP) in 1960 in South Africa to that in Swaziland?
Your answer should be compact. 0.34. What is the ratio of the Value added (% of GDP) of 1961 in South Africa to that in Swaziland?
Ensure brevity in your answer.  0.37. What is the ratio of the Value added (% of GDP) in 1962 in South Africa to that in Swaziland?
Keep it short and to the point. 0.31. What is the ratio of the Value added (% of GDP) of 1963 in South Africa to that in Swaziland?
Your answer should be very brief. 0.27. What is the ratio of the Value added (% of GDP) of 1960 in South Africa to that in Thailand?
Provide a short and direct response. 0.31. What is the ratio of the Value added (% of GDP) in 1961 in South Africa to that in Thailand?
Your answer should be compact. 0.32. What is the ratio of the Value added (% of GDP) in 1962 in South Africa to that in Thailand?
Offer a very short reply. 0.33. What is the ratio of the Value added (% of GDP) in 1963 in South Africa to that in Thailand?
Your response must be concise. 0.33. What is the ratio of the Value added (% of GDP) of 1960 in Sri Lanka to that in Sudan?
Your response must be concise. 0.57. What is the ratio of the Value added (% of GDP) of 1961 in Sri Lanka to that in Sudan?
Ensure brevity in your answer.  0.58. What is the ratio of the Value added (% of GDP) in 1962 in Sri Lanka to that in Sudan?
Provide a succinct answer. 0.56. What is the ratio of the Value added (% of GDP) of 1963 in Sri Lanka to that in Sudan?
Provide a short and direct response. 0.64. What is the ratio of the Value added (% of GDP) of 1960 in Sri Lanka to that in Swaziland?
Offer a terse response. 0.96. What is the ratio of the Value added (% of GDP) in 1961 in Sri Lanka to that in Swaziland?
Offer a terse response. 1.03. What is the ratio of the Value added (% of GDP) of 1962 in Sri Lanka to that in Swaziland?
Offer a very short reply. 0.85. What is the ratio of the Value added (% of GDP) of 1963 in Sri Lanka to that in Swaziland?
Give a very brief answer. 0.79. What is the ratio of the Value added (% of GDP) of 1960 in Sri Lanka to that in Thailand?
Your response must be concise. 0.87. What is the ratio of the Value added (% of GDP) of 1961 in Sri Lanka to that in Thailand?
Your response must be concise. 0.9. What is the ratio of the Value added (% of GDP) in 1962 in Sri Lanka to that in Thailand?
Make the answer very short. 0.9. What is the ratio of the Value added (% of GDP) in 1963 in Sri Lanka to that in Thailand?
Make the answer very short. 0.96. What is the ratio of the Value added (% of GDP) in 1960 in Sudan to that in Swaziland?
Offer a very short reply. 1.69. What is the ratio of the Value added (% of GDP) of 1961 in Sudan to that in Swaziland?
Provide a succinct answer. 1.78. What is the ratio of the Value added (% of GDP) in 1962 in Sudan to that in Swaziland?
Provide a succinct answer. 1.52. What is the ratio of the Value added (% of GDP) in 1963 in Sudan to that in Swaziland?
Keep it short and to the point. 1.23. What is the ratio of the Value added (% of GDP) of 1960 in Sudan to that in Thailand?
Give a very brief answer. 1.52. What is the ratio of the Value added (% of GDP) of 1961 in Sudan to that in Thailand?
Provide a short and direct response. 1.56. What is the ratio of the Value added (% of GDP) in 1962 in Sudan to that in Thailand?
Your answer should be very brief. 1.62. What is the ratio of the Value added (% of GDP) of 1963 in Sudan to that in Thailand?
Keep it short and to the point. 1.5. What is the ratio of the Value added (% of GDP) of 1960 in Swaziland to that in Thailand?
Make the answer very short. 0.9. What is the ratio of the Value added (% of GDP) of 1961 in Swaziland to that in Thailand?
Give a very brief answer. 0.88. What is the ratio of the Value added (% of GDP) in 1962 in Swaziland to that in Thailand?
Keep it short and to the point. 1.06. What is the ratio of the Value added (% of GDP) of 1963 in Swaziland to that in Thailand?
Give a very brief answer. 1.22. What is the difference between the highest and the second highest Value added (% of GDP) of 1960?
Give a very brief answer. 18.91. What is the difference between the highest and the second highest Value added (% of GDP) in 1961?
Your answer should be very brief. 20.15. What is the difference between the highest and the second highest Value added (% of GDP) of 1962?
Offer a terse response. 18.92. What is the difference between the highest and the second highest Value added (% of GDP) in 1963?
Make the answer very short. 9.32. What is the difference between the highest and the lowest Value added (% of GDP) in 1960?
Your response must be concise. 44.14. What is the difference between the highest and the lowest Value added (% of GDP) of 1961?
Your response must be concise. 44.45. What is the difference between the highest and the lowest Value added (% of GDP) in 1962?
Make the answer very short. 43.98. What is the difference between the highest and the lowest Value added (% of GDP) in 1963?
Your response must be concise. 38.79. 